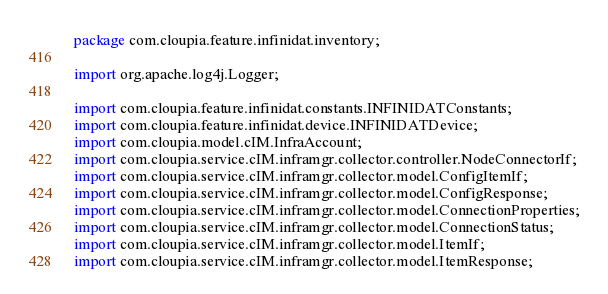Convert code to text. <code><loc_0><loc_0><loc_500><loc_500><_Java_>package com.cloupia.feature.infinidat.inventory;

import org.apache.log4j.Logger;

import com.cloupia.feature.infinidat.constants.INFINIDATConstants;
import com.cloupia.feature.infinidat.device.INFINIDATDevice;
import com.cloupia.model.cIM.InfraAccount;
import com.cloupia.service.cIM.inframgr.collector.controller.NodeConnectorIf;
import com.cloupia.service.cIM.inframgr.collector.model.ConfigItemIf;
import com.cloupia.service.cIM.inframgr.collector.model.ConfigResponse;
import com.cloupia.service.cIM.inframgr.collector.model.ConnectionProperties;
import com.cloupia.service.cIM.inframgr.collector.model.ConnectionStatus;
import com.cloupia.service.cIM.inframgr.collector.model.ItemIf;
import com.cloupia.service.cIM.inframgr.collector.model.ItemResponse;</code> 